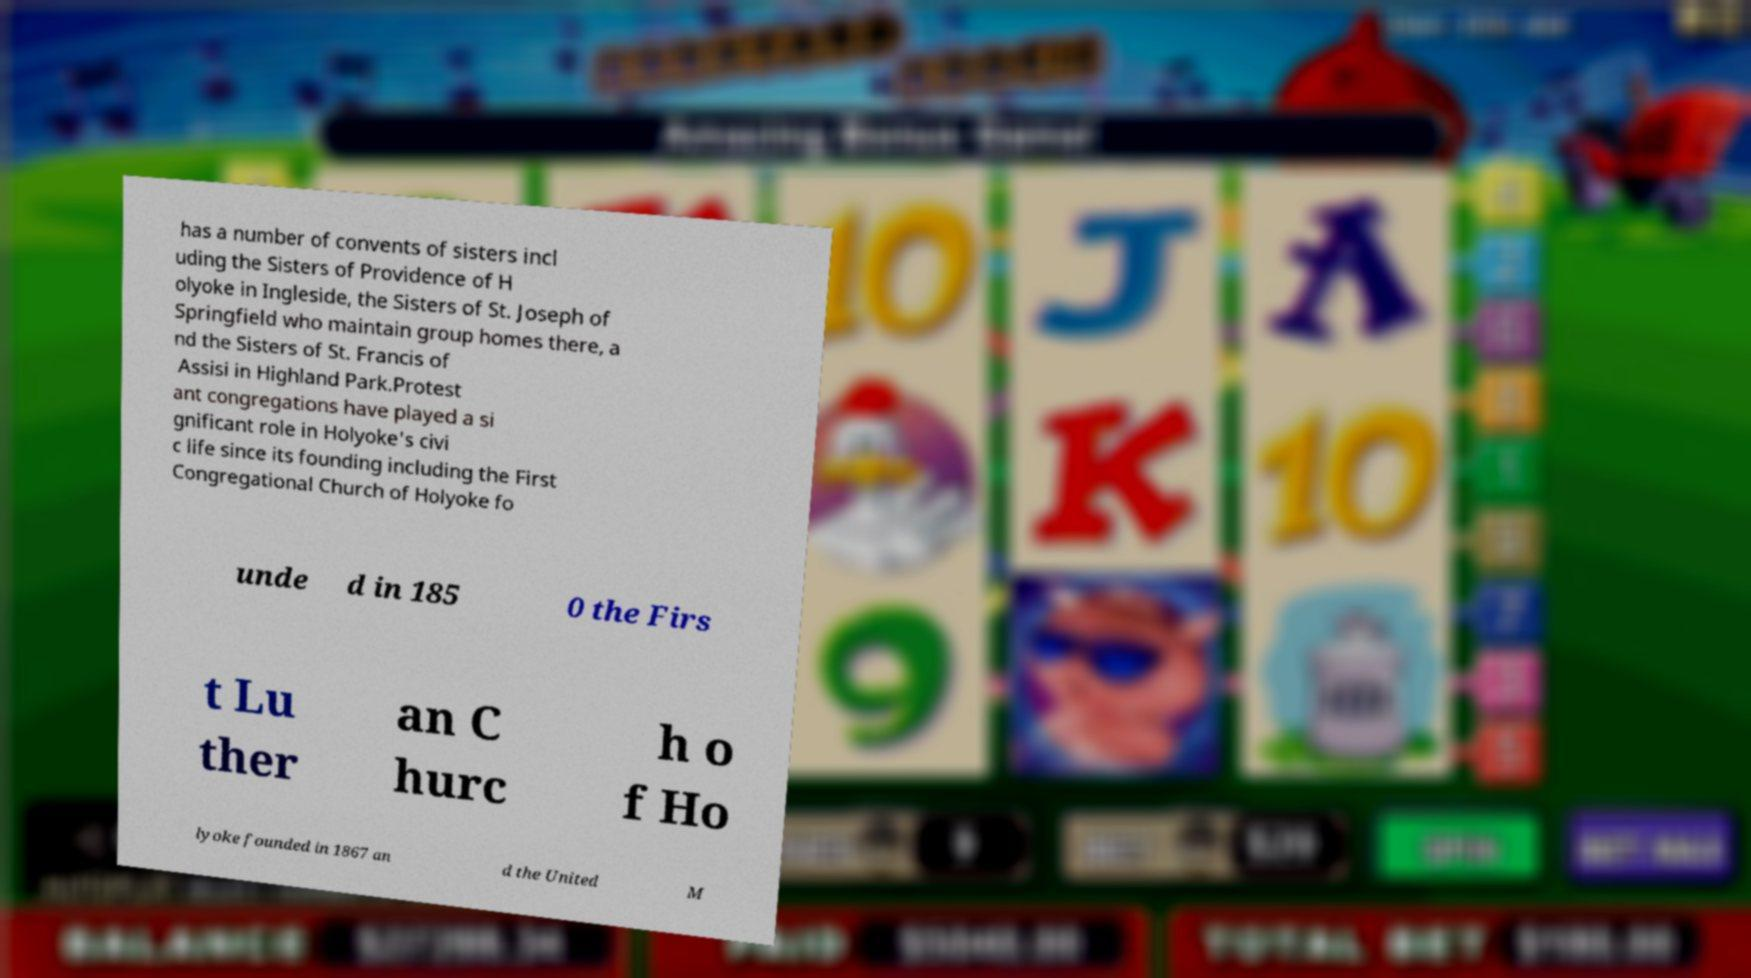There's text embedded in this image that I need extracted. Can you transcribe it verbatim? has a number of convents of sisters incl uding the Sisters of Providence of H olyoke in Ingleside, the Sisters of St. Joseph of Springfield who maintain group homes there, a nd the Sisters of St. Francis of Assisi in Highland Park.Protest ant congregations have played a si gnificant role in Holyoke's civi c life since its founding including the First Congregational Church of Holyoke fo unde d in 185 0 the Firs t Lu ther an C hurc h o f Ho lyoke founded in 1867 an d the United M 